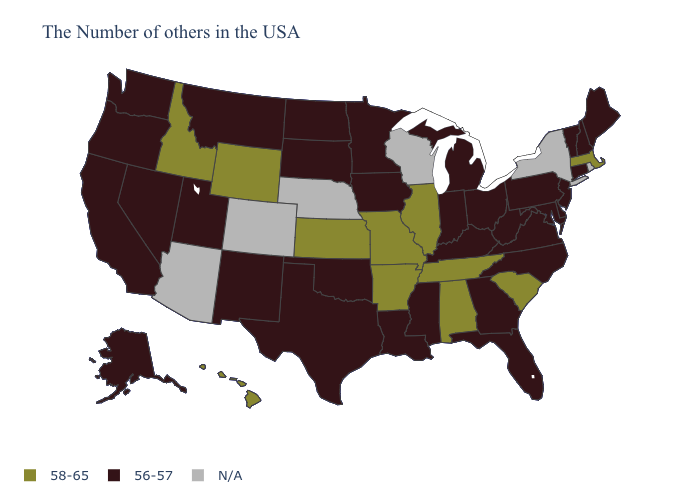What is the value of Ohio?
Give a very brief answer. 56-57. Which states have the lowest value in the West?
Give a very brief answer. New Mexico, Utah, Montana, Nevada, California, Washington, Oregon, Alaska. What is the highest value in the Northeast ?
Concise answer only. 58-65. What is the value of Missouri?
Answer briefly. 58-65. What is the value of Maine?
Answer briefly. 56-57. Name the states that have a value in the range 56-57?
Quick response, please. Maine, New Hampshire, Vermont, Connecticut, New Jersey, Delaware, Maryland, Pennsylvania, Virginia, North Carolina, West Virginia, Ohio, Florida, Georgia, Michigan, Kentucky, Indiana, Mississippi, Louisiana, Minnesota, Iowa, Oklahoma, Texas, South Dakota, North Dakota, New Mexico, Utah, Montana, Nevada, California, Washington, Oregon, Alaska. Name the states that have a value in the range N/A?
Short answer required. Rhode Island, New York, Wisconsin, Nebraska, Colorado, Arizona. What is the value of Michigan?
Short answer required. 56-57. Does the map have missing data?
Give a very brief answer. Yes. How many symbols are there in the legend?
Be succinct. 3. Which states have the lowest value in the Northeast?
Give a very brief answer. Maine, New Hampshire, Vermont, Connecticut, New Jersey, Pennsylvania. What is the lowest value in the South?
Concise answer only. 56-57. 